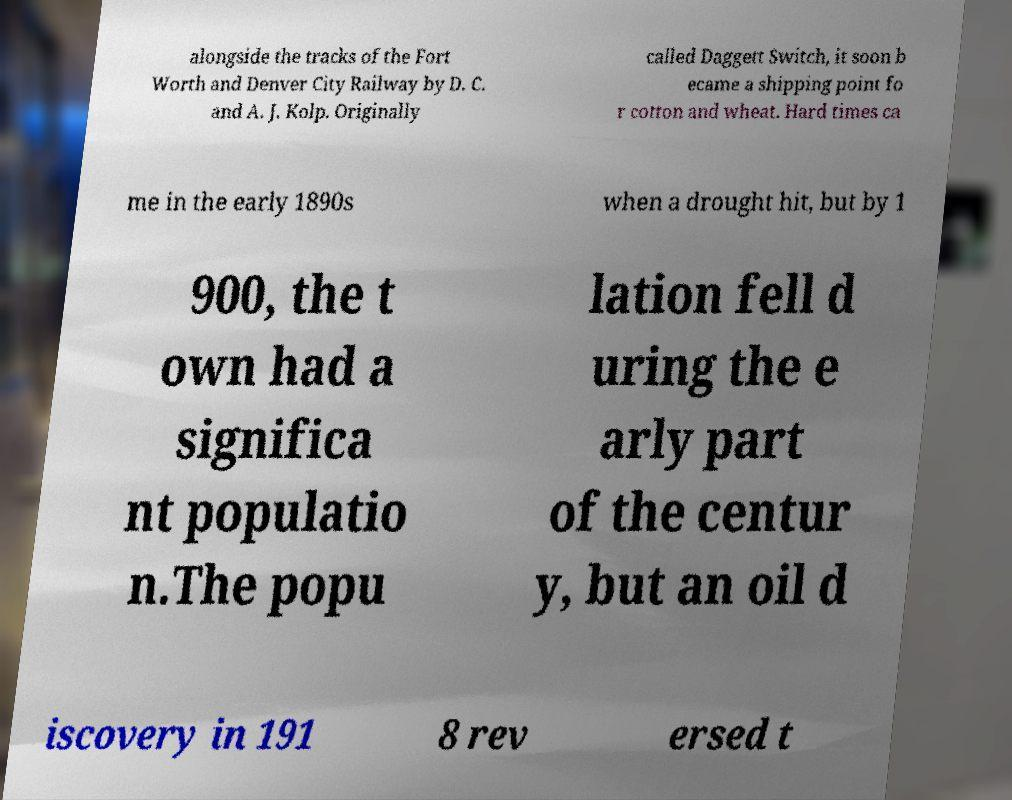Please read and relay the text visible in this image. What does it say? alongside the tracks of the Fort Worth and Denver City Railway by D. C. and A. J. Kolp. Originally called Daggett Switch, it soon b ecame a shipping point fo r cotton and wheat. Hard times ca me in the early 1890s when a drought hit, but by 1 900, the t own had a significa nt populatio n.The popu lation fell d uring the e arly part of the centur y, but an oil d iscovery in 191 8 rev ersed t 